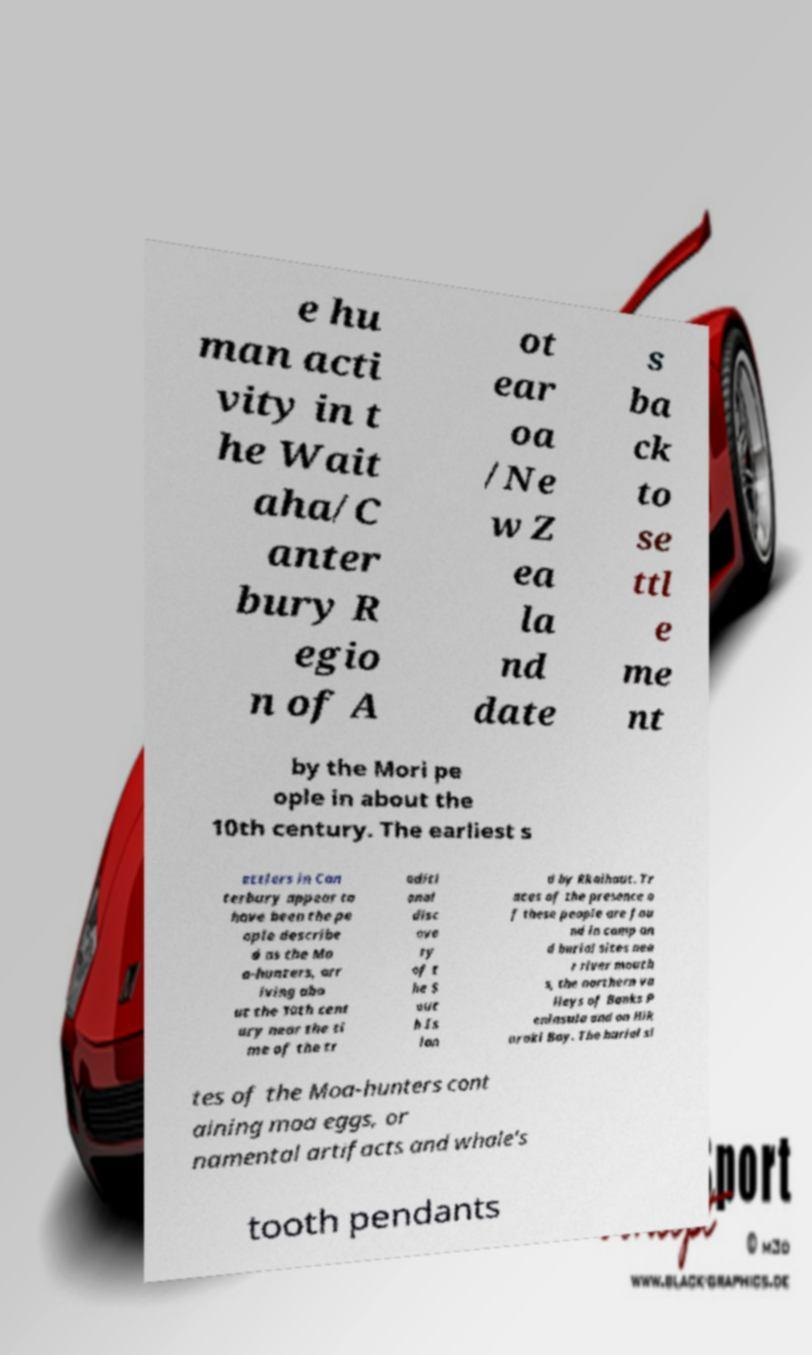Could you assist in decoding the text presented in this image and type it out clearly? e hu man acti vity in t he Wait aha/C anter bury R egio n of A ot ear oa /Ne w Z ea la nd date s ba ck to se ttl e me nt by the Mori pe ople in about the 10th century. The earliest s ettlers in Can terbury appear to have been the pe ople describe d as the Mo a-hunters, arr iving abo ut the 10th cent ury near the ti me of the tr aditi onal disc ove ry of t he S out h Is lan d by Rkaihaut. Tr aces of the presence o f these people are fou nd in camp an d burial sites nea r river mouth s, the northern va lleys of Banks P eninsula and on Hik uraki Bay. The burial si tes of the Moa-hunters cont aining moa eggs, or namental artifacts and whale's tooth pendants 